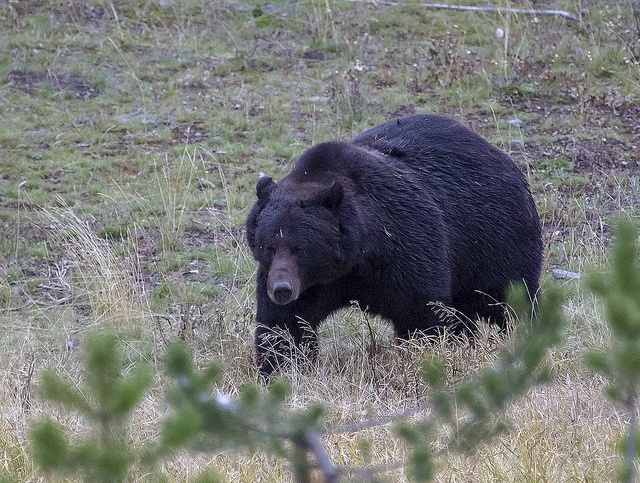Describe the objects in this image and their specific colors. I can see a bear in gray, black, navy, and darkgray tones in this image. 